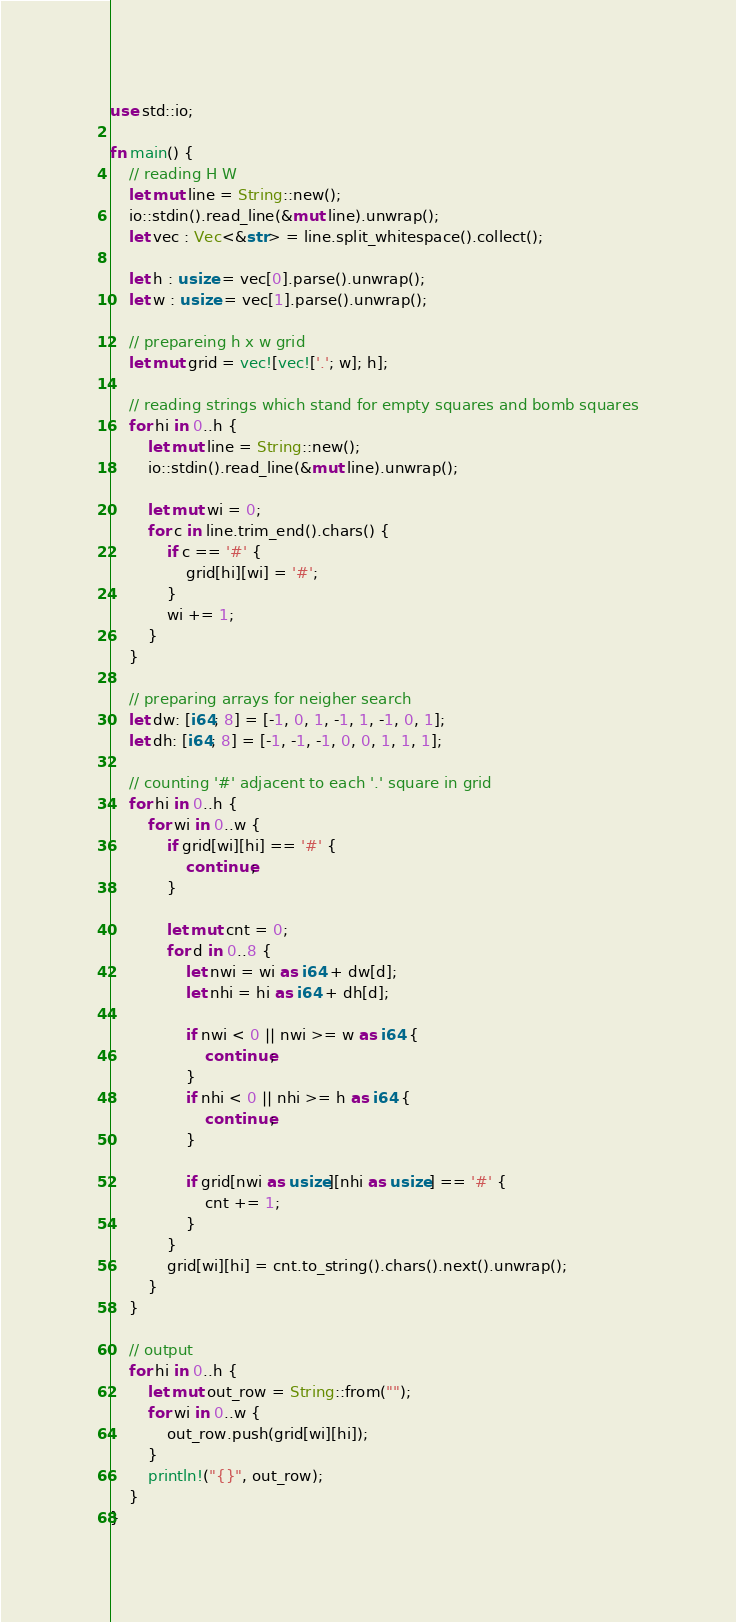<code> <loc_0><loc_0><loc_500><loc_500><_Rust_>use std::io;

fn main() {
	// reading H W 
	let mut line = String::new();
	io::stdin().read_line(&mut line).unwrap();
	let vec : Vec<&str> = line.split_whitespace().collect();

	let h : usize = vec[0].parse().unwrap();
	let w : usize = vec[1].parse().unwrap();

	// prepareing h x w grid
	let mut grid = vec![vec!['.'; w]; h];

	// reading strings which stand for empty squares and bomb squares
	for hi in 0..h {
		let mut line = String::new();
		io::stdin().read_line(&mut line).unwrap();
		
		let mut wi = 0;
		for c in line.trim_end().chars() {
			if c == '#' {
				grid[hi][wi] = '#';
			}
			wi += 1;
		}
	}
	
	// preparing arrays for neigher search
	let dw: [i64; 8] = [-1, 0, 1, -1, 1, -1, 0, 1];
	let dh: [i64; 8] = [-1, -1, -1, 0, 0, 1, 1, 1];

	// counting '#' adjacent to each '.' square in grid
	for hi in 0..h {
		for wi in 0..w {
			if grid[wi][hi] == '#' {
				continue;
			}

			let mut cnt = 0;
			for d in 0..8 {
				let nwi = wi as i64 + dw[d];
				let nhi = hi as i64 + dh[d];

				if nwi < 0 || nwi >= w as i64 {
					continue;
				}
				if nhi < 0 || nhi >= h as i64 {
					continue;
				}

				if grid[nwi as usize][nhi as usize] == '#' {
					cnt += 1;
				}
			}
			grid[wi][hi] = cnt.to_string().chars().next().unwrap();
		}
	}

	// output
	for hi in 0..h {
		let mut out_row = String::from("");
		for wi in 0..w {
			out_row.push(grid[wi][hi]);
		}
		println!("{}", out_row);
	}
}
</code> 